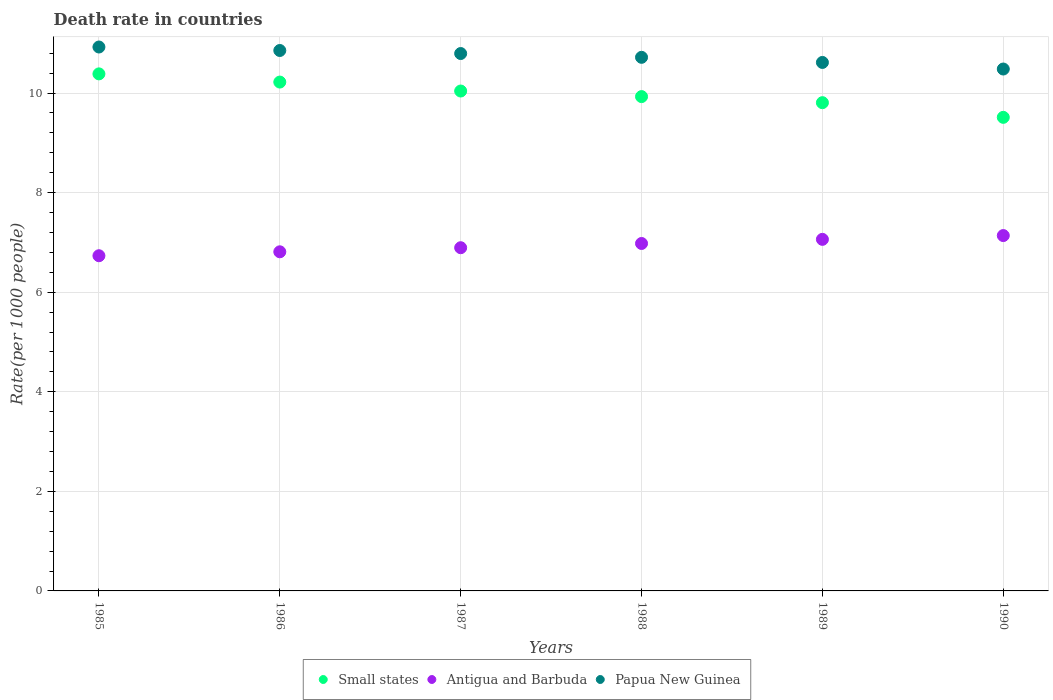What is the death rate in Small states in 1985?
Your response must be concise. 10.38. Across all years, what is the maximum death rate in Antigua and Barbuda?
Your answer should be very brief. 7.14. Across all years, what is the minimum death rate in Papua New Guinea?
Give a very brief answer. 10.48. In which year was the death rate in Antigua and Barbuda maximum?
Offer a terse response. 1990. What is the total death rate in Papua New Guinea in the graph?
Provide a succinct answer. 64.38. What is the difference between the death rate in Small states in 1986 and that in 1989?
Your response must be concise. 0.41. What is the difference between the death rate in Small states in 1989 and the death rate in Antigua and Barbuda in 1990?
Ensure brevity in your answer.  2.67. What is the average death rate in Papua New Guinea per year?
Give a very brief answer. 10.73. In the year 1985, what is the difference between the death rate in Small states and death rate in Papua New Guinea?
Your response must be concise. -0.54. In how many years, is the death rate in Small states greater than 7.6?
Ensure brevity in your answer.  6. What is the ratio of the death rate in Antigua and Barbuda in 1987 to that in 1989?
Your answer should be compact. 0.98. Is the death rate in Papua New Guinea in 1986 less than that in 1990?
Ensure brevity in your answer.  No. Is the difference between the death rate in Small states in 1985 and 1987 greater than the difference between the death rate in Papua New Guinea in 1985 and 1987?
Offer a very short reply. Yes. What is the difference between the highest and the second highest death rate in Papua New Guinea?
Offer a very short reply. 0.07. What is the difference between the highest and the lowest death rate in Papua New Guinea?
Offer a very short reply. 0.44. Is it the case that in every year, the sum of the death rate in Antigua and Barbuda and death rate in Papua New Guinea  is greater than the death rate in Small states?
Give a very brief answer. Yes. Does the death rate in Papua New Guinea monotonically increase over the years?
Keep it short and to the point. No. How many dotlines are there?
Keep it short and to the point. 3. How many years are there in the graph?
Your response must be concise. 6. Are the values on the major ticks of Y-axis written in scientific E-notation?
Offer a very short reply. No. How many legend labels are there?
Offer a terse response. 3. What is the title of the graph?
Provide a succinct answer. Death rate in countries. What is the label or title of the Y-axis?
Offer a very short reply. Rate(per 1000 people). What is the Rate(per 1000 people) in Small states in 1985?
Your answer should be very brief. 10.38. What is the Rate(per 1000 people) in Antigua and Barbuda in 1985?
Offer a very short reply. 6.73. What is the Rate(per 1000 people) of Papua New Guinea in 1985?
Your answer should be compact. 10.92. What is the Rate(per 1000 people) in Small states in 1986?
Your answer should be compact. 10.22. What is the Rate(per 1000 people) in Antigua and Barbuda in 1986?
Provide a short and direct response. 6.81. What is the Rate(per 1000 people) in Papua New Guinea in 1986?
Provide a short and direct response. 10.85. What is the Rate(per 1000 people) of Small states in 1987?
Provide a short and direct response. 10.04. What is the Rate(per 1000 people) in Antigua and Barbuda in 1987?
Give a very brief answer. 6.89. What is the Rate(per 1000 people) in Papua New Guinea in 1987?
Offer a terse response. 10.79. What is the Rate(per 1000 people) in Small states in 1988?
Offer a very short reply. 9.93. What is the Rate(per 1000 people) in Antigua and Barbuda in 1988?
Keep it short and to the point. 6.98. What is the Rate(per 1000 people) of Papua New Guinea in 1988?
Your response must be concise. 10.72. What is the Rate(per 1000 people) of Small states in 1989?
Your response must be concise. 9.81. What is the Rate(per 1000 people) in Antigua and Barbuda in 1989?
Your answer should be compact. 7.06. What is the Rate(per 1000 people) of Papua New Guinea in 1989?
Your response must be concise. 10.61. What is the Rate(per 1000 people) of Small states in 1990?
Offer a terse response. 9.51. What is the Rate(per 1000 people) in Antigua and Barbuda in 1990?
Your answer should be very brief. 7.14. What is the Rate(per 1000 people) in Papua New Guinea in 1990?
Provide a short and direct response. 10.48. Across all years, what is the maximum Rate(per 1000 people) in Small states?
Ensure brevity in your answer.  10.38. Across all years, what is the maximum Rate(per 1000 people) in Antigua and Barbuda?
Keep it short and to the point. 7.14. Across all years, what is the maximum Rate(per 1000 people) in Papua New Guinea?
Offer a terse response. 10.92. Across all years, what is the minimum Rate(per 1000 people) of Small states?
Provide a short and direct response. 9.51. Across all years, what is the minimum Rate(per 1000 people) of Antigua and Barbuda?
Give a very brief answer. 6.73. Across all years, what is the minimum Rate(per 1000 people) of Papua New Guinea?
Offer a terse response. 10.48. What is the total Rate(per 1000 people) of Small states in the graph?
Provide a succinct answer. 59.89. What is the total Rate(per 1000 people) in Antigua and Barbuda in the graph?
Make the answer very short. 41.61. What is the total Rate(per 1000 people) in Papua New Guinea in the graph?
Your response must be concise. 64.38. What is the difference between the Rate(per 1000 people) in Small states in 1985 and that in 1986?
Keep it short and to the point. 0.16. What is the difference between the Rate(per 1000 people) in Antigua and Barbuda in 1985 and that in 1986?
Your answer should be very brief. -0.08. What is the difference between the Rate(per 1000 people) in Papua New Guinea in 1985 and that in 1986?
Give a very brief answer. 0.07. What is the difference between the Rate(per 1000 people) in Small states in 1985 and that in 1987?
Your answer should be compact. 0.34. What is the difference between the Rate(per 1000 people) of Antigua and Barbuda in 1985 and that in 1987?
Your answer should be compact. -0.16. What is the difference between the Rate(per 1000 people) of Papua New Guinea in 1985 and that in 1987?
Give a very brief answer. 0.13. What is the difference between the Rate(per 1000 people) in Small states in 1985 and that in 1988?
Provide a short and direct response. 0.46. What is the difference between the Rate(per 1000 people) in Antigua and Barbuda in 1985 and that in 1988?
Ensure brevity in your answer.  -0.25. What is the difference between the Rate(per 1000 people) in Papua New Guinea in 1985 and that in 1988?
Give a very brief answer. 0.21. What is the difference between the Rate(per 1000 people) of Small states in 1985 and that in 1989?
Ensure brevity in your answer.  0.58. What is the difference between the Rate(per 1000 people) of Antigua and Barbuda in 1985 and that in 1989?
Your answer should be very brief. -0.33. What is the difference between the Rate(per 1000 people) in Papua New Guinea in 1985 and that in 1989?
Offer a very short reply. 0.31. What is the difference between the Rate(per 1000 people) in Small states in 1985 and that in 1990?
Give a very brief answer. 0.87. What is the difference between the Rate(per 1000 people) of Antigua and Barbuda in 1985 and that in 1990?
Offer a very short reply. -0.41. What is the difference between the Rate(per 1000 people) in Papua New Guinea in 1985 and that in 1990?
Give a very brief answer. 0.44. What is the difference between the Rate(per 1000 people) of Small states in 1986 and that in 1987?
Provide a short and direct response. 0.18. What is the difference between the Rate(per 1000 people) of Antigua and Barbuda in 1986 and that in 1987?
Ensure brevity in your answer.  -0.08. What is the difference between the Rate(per 1000 people) in Papua New Guinea in 1986 and that in 1987?
Ensure brevity in your answer.  0.06. What is the difference between the Rate(per 1000 people) in Small states in 1986 and that in 1988?
Your response must be concise. 0.29. What is the difference between the Rate(per 1000 people) of Antigua and Barbuda in 1986 and that in 1988?
Ensure brevity in your answer.  -0.17. What is the difference between the Rate(per 1000 people) of Papua New Guinea in 1986 and that in 1988?
Offer a terse response. 0.14. What is the difference between the Rate(per 1000 people) in Small states in 1986 and that in 1989?
Offer a terse response. 0.41. What is the difference between the Rate(per 1000 people) in Papua New Guinea in 1986 and that in 1989?
Make the answer very short. 0.24. What is the difference between the Rate(per 1000 people) of Small states in 1986 and that in 1990?
Offer a terse response. 0.71. What is the difference between the Rate(per 1000 people) of Antigua and Barbuda in 1986 and that in 1990?
Provide a short and direct response. -0.33. What is the difference between the Rate(per 1000 people) of Papua New Guinea in 1986 and that in 1990?
Ensure brevity in your answer.  0.37. What is the difference between the Rate(per 1000 people) of Small states in 1987 and that in 1988?
Provide a short and direct response. 0.11. What is the difference between the Rate(per 1000 people) in Antigua and Barbuda in 1987 and that in 1988?
Ensure brevity in your answer.  -0.09. What is the difference between the Rate(per 1000 people) of Papua New Guinea in 1987 and that in 1988?
Ensure brevity in your answer.  0.08. What is the difference between the Rate(per 1000 people) in Small states in 1987 and that in 1989?
Your answer should be compact. 0.23. What is the difference between the Rate(per 1000 people) of Antigua and Barbuda in 1987 and that in 1989?
Give a very brief answer. -0.17. What is the difference between the Rate(per 1000 people) in Papua New Guinea in 1987 and that in 1989?
Your response must be concise. 0.18. What is the difference between the Rate(per 1000 people) in Small states in 1987 and that in 1990?
Your answer should be compact. 0.53. What is the difference between the Rate(per 1000 people) in Antigua and Barbuda in 1987 and that in 1990?
Make the answer very short. -0.24. What is the difference between the Rate(per 1000 people) of Papua New Guinea in 1987 and that in 1990?
Your response must be concise. 0.31. What is the difference between the Rate(per 1000 people) of Small states in 1988 and that in 1989?
Ensure brevity in your answer.  0.12. What is the difference between the Rate(per 1000 people) in Antigua and Barbuda in 1988 and that in 1989?
Offer a very short reply. -0.08. What is the difference between the Rate(per 1000 people) in Papua New Guinea in 1988 and that in 1989?
Provide a short and direct response. 0.1. What is the difference between the Rate(per 1000 people) of Small states in 1988 and that in 1990?
Offer a terse response. 0.42. What is the difference between the Rate(per 1000 people) of Antigua and Barbuda in 1988 and that in 1990?
Ensure brevity in your answer.  -0.16. What is the difference between the Rate(per 1000 people) of Papua New Guinea in 1988 and that in 1990?
Keep it short and to the point. 0.23. What is the difference between the Rate(per 1000 people) of Small states in 1989 and that in 1990?
Provide a succinct answer. 0.29. What is the difference between the Rate(per 1000 people) in Antigua and Barbuda in 1989 and that in 1990?
Provide a short and direct response. -0.08. What is the difference between the Rate(per 1000 people) in Papua New Guinea in 1989 and that in 1990?
Give a very brief answer. 0.13. What is the difference between the Rate(per 1000 people) of Small states in 1985 and the Rate(per 1000 people) of Antigua and Barbuda in 1986?
Keep it short and to the point. 3.57. What is the difference between the Rate(per 1000 people) in Small states in 1985 and the Rate(per 1000 people) in Papua New Guinea in 1986?
Provide a succinct answer. -0.47. What is the difference between the Rate(per 1000 people) in Antigua and Barbuda in 1985 and the Rate(per 1000 people) in Papua New Guinea in 1986?
Your answer should be very brief. -4.12. What is the difference between the Rate(per 1000 people) of Small states in 1985 and the Rate(per 1000 people) of Antigua and Barbuda in 1987?
Offer a terse response. 3.49. What is the difference between the Rate(per 1000 people) in Small states in 1985 and the Rate(per 1000 people) in Papua New Guinea in 1987?
Give a very brief answer. -0.41. What is the difference between the Rate(per 1000 people) of Antigua and Barbuda in 1985 and the Rate(per 1000 people) of Papua New Guinea in 1987?
Your answer should be compact. -4.06. What is the difference between the Rate(per 1000 people) of Small states in 1985 and the Rate(per 1000 people) of Antigua and Barbuda in 1988?
Ensure brevity in your answer.  3.41. What is the difference between the Rate(per 1000 people) in Small states in 1985 and the Rate(per 1000 people) in Papua New Guinea in 1988?
Provide a succinct answer. -0.33. What is the difference between the Rate(per 1000 people) in Antigua and Barbuda in 1985 and the Rate(per 1000 people) in Papua New Guinea in 1988?
Offer a very short reply. -3.98. What is the difference between the Rate(per 1000 people) of Small states in 1985 and the Rate(per 1000 people) of Antigua and Barbuda in 1989?
Your answer should be very brief. 3.32. What is the difference between the Rate(per 1000 people) of Small states in 1985 and the Rate(per 1000 people) of Papua New Guinea in 1989?
Keep it short and to the point. -0.23. What is the difference between the Rate(per 1000 people) in Antigua and Barbuda in 1985 and the Rate(per 1000 people) in Papua New Guinea in 1989?
Make the answer very short. -3.88. What is the difference between the Rate(per 1000 people) in Small states in 1985 and the Rate(per 1000 people) in Antigua and Barbuda in 1990?
Ensure brevity in your answer.  3.25. What is the difference between the Rate(per 1000 people) in Small states in 1985 and the Rate(per 1000 people) in Papua New Guinea in 1990?
Your answer should be compact. -0.1. What is the difference between the Rate(per 1000 people) in Antigua and Barbuda in 1985 and the Rate(per 1000 people) in Papua New Guinea in 1990?
Your answer should be very brief. -3.75. What is the difference between the Rate(per 1000 people) of Small states in 1986 and the Rate(per 1000 people) of Antigua and Barbuda in 1987?
Offer a very short reply. 3.33. What is the difference between the Rate(per 1000 people) of Small states in 1986 and the Rate(per 1000 people) of Papua New Guinea in 1987?
Your answer should be compact. -0.57. What is the difference between the Rate(per 1000 people) of Antigua and Barbuda in 1986 and the Rate(per 1000 people) of Papua New Guinea in 1987?
Keep it short and to the point. -3.98. What is the difference between the Rate(per 1000 people) in Small states in 1986 and the Rate(per 1000 people) in Antigua and Barbuda in 1988?
Your answer should be very brief. 3.24. What is the difference between the Rate(per 1000 people) of Small states in 1986 and the Rate(per 1000 people) of Papua New Guinea in 1988?
Make the answer very short. -0.5. What is the difference between the Rate(per 1000 people) of Antigua and Barbuda in 1986 and the Rate(per 1000 people) of Papua New Guinea in 1988?
Make the answer very short. -3.91. What is the difference between the Rate(per 1000 people) in Small states in 1986 and the Rate(per 1000 people) in Antigua and Barbuda in 1989?
Ensure brevity in your answer.  3.16. What is the difference between the Rate(per 1000 people) of Small states in 1986 and the Rate(per 1000 people) of Papua New Guinea in 1989?
Offer a terse response. -0.39. What is the difference between the Rate(per 1000 people) in Antigua and Barbuda in 1986 and the Rate(per 1000 people) in Papua New Guinea in 1989?
Keep it short and to the point. -3.8. What is the difference between the Rate(per 1000 people) in Small states in 1986 and the Rate(per 1000 people) in Antigua and Barbuda in 1990?
Give a very brief answer. 3.08. What is the difference between the Rate(per 1000 people) of Small states in 1986 and the Rate(per 1000 people) of Papua New Guinea in 1990?
Ensure brevity in your answer.  -0.26. What is the difference between the Rate(per 1000 people) in Antigua and Barbuda in 1986 and the Rate(per 1000 people) in Papua New Guinea in 1990?
Ensure brevity in your answer.  -3.67. What is the difference between the Rate(per 1000 people) in Small states in 1987 and the Rate(per 1000 people) in Antigua and Barbuda in 1988?
Ensure brevity in your answer.  3.06. What is the difference between the Rate(per 1000 people) in Small states in 1987 and the Rate(per 1000 people) in Papua New Guinea in 1988?
Your response must be concise. -0.68. What is the difference between the Rate(per 1000 people) of Antigua and Barbuda in 1987 and the Rate(per 1000 people) of Papua New Guinea in 1988?
Give a very brief answer. -3.82. What is the difference between the Rate(per 1000 people) in Small states in 1987 and the Rate(per 1000 people) in Antigua and Barbuda in 1989?
Offer a terse response. 2.98. What is the difference between the Rate(per 1000 people) in Small states in 1987 and the Rate(per 1000 people) in Papua New Guinea in 1989?
Ensure brevity in your answer.  -0.57. What is the difference between the Rate(per 1000 people) of Antigua and Barbuda in 1987 and the Rate(per 1000 people) of Papua New Guinea in 1989?
Offer a terse response. -3.72. What is the difference between the Rate(per 1000 people) of Small states in 1987 and the Rate(per 1000 people) of Antigua and Barbuda in 1990?
Give a very brief answer. 2.9. What is the difference between the Rate(per 1000 people) in Small states in 1987 and the Rate(per 1000 people) in Papua New Guinea in 1990?
Ensure brevity in your answer.  -0.44. What is the difference between the Rate(per 1000 people) of Antigua and Barbuda in 1987 and the Rate(per 1000 people) of Papua New Guinea in 1990?
Ensure brevity in your answer.  -3.59. What is the difference between the Rate(per 1000 people) in Small states in 1988 and the Rate(per 1000 people) in Antigua and Barbuda in 1989?
Your answer should be compact. 2.87. What is the difference between the Rate(per 1000 people) in Small states in 1988 and the Rate(per 1000 people) in Papua New Guinea in 1989?
Ensure brevity in your answer.  -0.69. What is the difference between the Rate(per 1000 people) of Antigua and Barbuda in 1988 and the Rate(per 1000 people) of Papua New Guinea in 1989?
Provide a succinct answer. -3.64. What is the difference between the Rate(per 1000 people) of Small states in 1988 and the Rate(per 1000 people) of Antigua and Barbuda in 1990?
Keep it short and to the point. 2.79. What is the difference between the Rate(per 1000 people) in Small states in 1988 and the Rate(per 1000 people) in Papua New Guinea in 1990?
Provide a succinct answer. -0.55. What is the difference between the Rate(per 1000 people) in Antigua and Barbuda in 1988 and the Rate(per 1000 people) in Papua New Guinea in 1990?
Provide a succinct answer. -3.5. What is the difference between the Rate(per 1000 people) of Small states in 1989 and the Rate(per 1000 people) of Antigua and Barbuda in 1990?
Offer a very short reply. 2.67. What is the difference between the Rate(per 1000 people) in Small states in 1989 and the Rate(per 1000 people) in Papua New Guinea in 1990?
Your response must be concise. -0.68. What is the difference between the Rate(per 1000 people) in Antigua and Barbuda in 1989 and the Rate(per 1000 people) in Papua New Guinea in 1990?
Keep it short and to the point. -3.42. What is the average Rate(per 1000 people) of Small states per year?
Offer a very short reply. 9.98. What is the average Rate(per 1000 people) of Antigua and Barbuda per year?
Keep it short and to the point. 6.94. What is the average Rate(per 1000 people) in Papua New Guinea per year?
Your answer should be compact. 10.73. In the year 1985, what is the difference between the Rate(per 1000 people) in Small states and Rate(per 1000 people) in Antigua and Barbuda?
Make the answer very short. 3.65. In the year 1985, what is the difference between the Rate(per 1000 people) in Small states and Rate(per 1000 people) in Papua New Guinea?
Your response must be concise. -0.54. In the year 1985, what is the difference between the Rate(per 1000 people) of Antigua and Barbuda and Rate(per 1000 people) of Papua New Guinea?
Provide a succinct answer. -4.19. In the year 1986, what is the difference between the Rate(per 1000 people) in Small states and Rate(per 1000 people) in Antigua and Barbuda?
Keep it short and to the point. 3.41. In the year 1986, what is the difference between the Rate(per 1000 people) in Small states and Rate(per 1000 people) in Papua New Guinea?
Offer a very short reply. -0.63. In the year 1986, what is the difference between the Rate(per 1000 people) in Antigua and Barbuda and Rate(per 1000 people) in Papua New Guinea?
Make the answer very short. -4.04. In the year 1987, what is the difference between the Rate(per 1000 people) of Small states and Rate(per 1000 people) of Antigua and Barbuda?
Keep it short and to the point. 3.15. In the year 1987, what is the difference between the Rate(per 1000 people) in Small states and Rate(per 1000 people) in Papua New Guinea?
Your answer should be compact. -0.75. In the year 1988, what is the difference between the Rate(per 1000 people) of Small states and Rate(per 1000 people) of Antigua and Barbuda?
Your answer should be compact. 2.95. In the year 1988, what is the difference between the Rate(per 1000 people) of Small states and Rate(per 1000 people) of Papua New Guinea?
Keep it short and to the point. -0.79. In the year 1988, what is the difference between the Rate(per 1000 people) of Antigua and Barbuda and Rate(per 1000 people) of Papua New Guinea?
Offer a very short reply. -3.74. In the year 1989, what is the difference between the Rate(per 1000 people) in Small states and Rate(per 1000 people) in Antigua and Barbuda?
Your answer should be compact. 2.74. In the year 1989, what is the difference between the Rate(per 1000 people) of Small states and Rate(per 1000 people) of Papua New Guinea?
Provide a short and direct response. -0.81. In the year 1989, what is the difference between the Rate(per 1000 people) of Antigua and Barbuda and Rate(per 1000 people) of Papua New Guinea?
Give a very brief answer. -3.55. In the year 1990, what is the difference between the Rate(per 1000 people) in Small states and Rate(per 1000 people) in Antigua and Barbuda?
Offer a terse response. 2.37. In the year 1990, what is the difference between the Rate(per 1000 people) of Small states and Rate(per 1000 people) of Papua New Guinea?
Your answer should be compact. -0.97. In the year 1990, what is the difference between the Rate(per 1000 people) of Antigua and Barbuda and Rate(per 1000 people) of Papua New Guinea?
Keep it short and to the point. -3.35. What is the ratio of the Rate(per 1000 people) in Small states in 1985 to that in 1986?
Make the answer very short. 1.02. What is the ratio of the Rate(per 1000 people) in Antigua and Barbuda in 1985 to that in 1986?
Your response must be concise. 0.99. What is the ratio of the Rate(per 1000 people) in Papua New Guinea in 1985 to that in 1986?
Your response must be concise. 1.01. What is the ratio of the Rate(per 1000 people) in Small states in 1985 to that in 1987?
Give a very brief answer. 1.03. What is the ratio of the Rate(per 1000 people) of Antigua and Barbuda in 1985 to that in 1987?
Provide a short and direct response. 0.98. What is the ratio of the Rate(per 1000 people) of Papua New Guinea in 1985 to that in 1987?
Your answer should be compact. 1.01. What is the ratio of the Rate(per 1000 people) of Small states in 1985 to that in 1988?
Your response must be concise. 1.05. What is the ratio of the Rate(per 1000 people) in Antigua and Barbuda in 1985 to that in 1988?
Provide a short and direct response. 0.96. What is the ratio of the Rate(per 1000 people) in Papua New Guinea in 1985 to that in 1988?
Provide a short and direct response. 1.02. What is the ratio of the Rate(per 1000 people) in Small states in 1985 to that in 1989?
Your answer should be very brief. 1.06. What is the ratio of the Rate(per 1000 people) in Antigua and Barbuda in 1985 to that in 1989?
Your answer should be compact. 0.95. What is the ratio of the Rate(per 1000 people) of Papua New Guinea in 1985 to that in 1989?
Give a very brief answer. 1.03. What is the ratio of the Rate(per 1000 people) of Small states in 1985 to that in 1990?
Provide a short and direct response. 1.09. What is the ratio of the Rate(per 1000 people) in Antigua and Barbuda in 1985 to that in 1990?
Your answer should be compact. 0.94. What is the ratio of the Rate(per 1000 people) in Papua New Guinea in 1985 to that in 1990?
Provide a succinct answer. 1.04. What is the ratio of the Rate(per 1000 people) in Small states in 1986 to that in 1987?
Provide a succinct answer. 1.02. What is the ratio of the Rate(per 1000 people) of Small states in 1986 to that in 1988?
Provide a short and direct response. 1.03. What is the ratio of the Rate(per 1000 people) of Antigua and Barbuda in 1986 to that in 1988?
Your response must be concise. 0.98. What is the ratio of the Rate(per 1000 people) of Papua New Guinea in 1986 to that in 1988?
Your answer should be compact. 1.01. What is the ratio of the Rate(per 1000 people) of Small states in 1986 to that in 1989?
Offer a terse response. 1.04. What is the ratio of the Rate(per 1000 people) of Antigua and Barbuda in 1986 to that in 1989?
Offer a terse response. 0.96. What is the ratio of the Rate(per 1000 people) of Papua New Guinea in 1986 to that in 1989?
Offer a very short reply. 1.02. What is the ratio of the Rate(per 1000 people) in Small states in 1986 to that in 1990?
Provide a short and direct response. 1.07. What is the ratio of the Rate(per 1000 people) of Antigua and Barbuda in 1986 to that in 1990?
Make the answer very short. 0.95. What is the ratio of the Rate(per 1000 people) of Papua New Guinea in 1986 to that in 1990?
Make the answer very short. 1.04. What is the ratio of the Rate(per 1000 people) in Small states in 1987 to that in 1988?
Provide a short and direct response. 1.01. What is the ratio of the Rate(per 1000 people) in Papua New Guinea in 1987 to that in 1988?
Offer a terse response. 1.01. What is the ratio of the Rate(per 1000 people) in Small states in 1987 to that in 1989?
Keep it short and to the point. 1.02. What is the ratio of the Rate(per 1000 people) of Antigua and Barbuda in 1987 to that in 1989?
Give a very brief answer. 0.98. What is the ratio of the Rate(per 1000 people) of Papua New Guinea in 1987 to that in 1989?
Make the answer very short. 1.02. What is the ratio of the Rate(per 1000 people) of Small states in 1987 to that in 1990?
Provide a succinct answer. 1.06. What is the ratio of the Rate(per 1000 people) of Antigua and Barbuda in 1987 to that in 1990?
Make the answer very short. 0.97. What is the ratio of the Rate(per 1000 people) in Papua New Guinea in 1987 to that in 1990?
Offer a terse response. 1.03. What is the ratio of the Rate(per 1000 people) of Small states in 1988 to that in 1989?
Your response must be concise. 1.01. What is the ratio of the Rate(per 1000 people) of Papua New Guinea in 1988 to that in 1989?
Your answer should be compact. 1.01. What is the ratio of the Rate(per 1000 people) of Small states in 1988 to that in 1990?
Your answer should be very brief. 1.04. What is the ratio of the Rate(per 1000 people) of Antigua and Barbuda in 1988 to that in 1990?
Offer a very short reply. 0.98. What is the ratio of the Rate(per 1000 people) in Papua New Guinea in 1988 to that in 1990?
Your answer should be very brief. 1.02. What is the ratio of the Rate(per 1000 people) in Small states in 1989 to that in 1990?
Your answer should be compact. 1.03. What is the ratio of the Rate(per 1000 people) of Antigua and Barbuda in 1989 to that in 1990?
Your answer should be very brief. 0.99. What is the ratio of the Rate(per 1000 people) of Papua New Guinea in 1989 to that in 1990?
Provide a short and direct response. 1.01. What is the difference between the highest and the second highest Rate(per 1000 people) in Small states?
Make the answer very short. 0.16. What is the difference between the highest and the second highest Rate(per 1000 people) of Antigua and Barbuda?
Give a very brief answer. 0.08. What is the difference between the highest and the second highest Rate(per 1000 people) in Papua New Guinea?
Offer a terse response. 0.07. What is the difference between the highest and the lowest Rate(per 1000 people) of Small states?
Your response must be concise. 0.87. What is the difference between the highest and the lowest Rate(per 1000 people) of Antigua and Barbuda?
Give a very brief answer. 0.41. What is the difference between the highest and the lowest Rate(per 1000 people) in Papua New Guinea?
Your response must be concise. 0.44. 